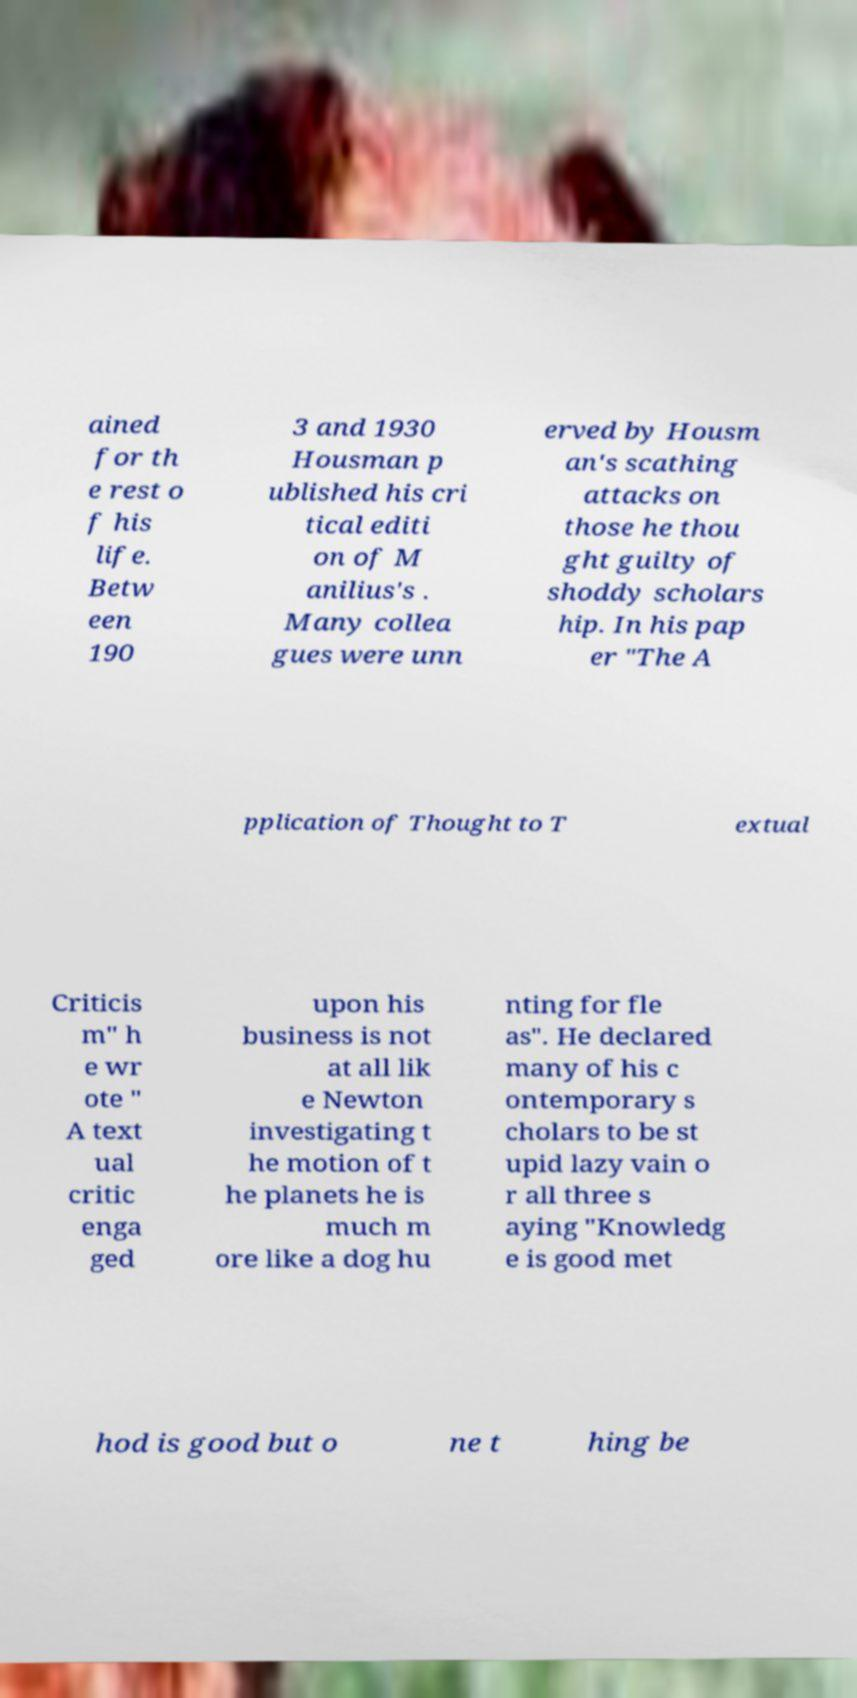Can you read and provide the text displayed in the image?This photo seems to have some interesting text. Can you extract and type it out for me? ained for th e rest o f his life. Betw een 190 3 and 1930 Housman p ublished his cri tical editi on of M anilius's . Many collea gues were unn erved by Housm an's scathing attacks on those he thou ght guilty of shoddy scholars hip. In his pap er "The A pplication of Thought to T extual Criticis m" h e wr ote " A text ual critic enga ged upon his business is not at all lik e Newton investigating t he motion of t he planets he is much m ore like a dog hu nting for fle as". He declared many of his c ontemporary s cholars to be st upid lazy vain o r all three s aying "Knowledg e is good met hod is good but o ne t hing be 